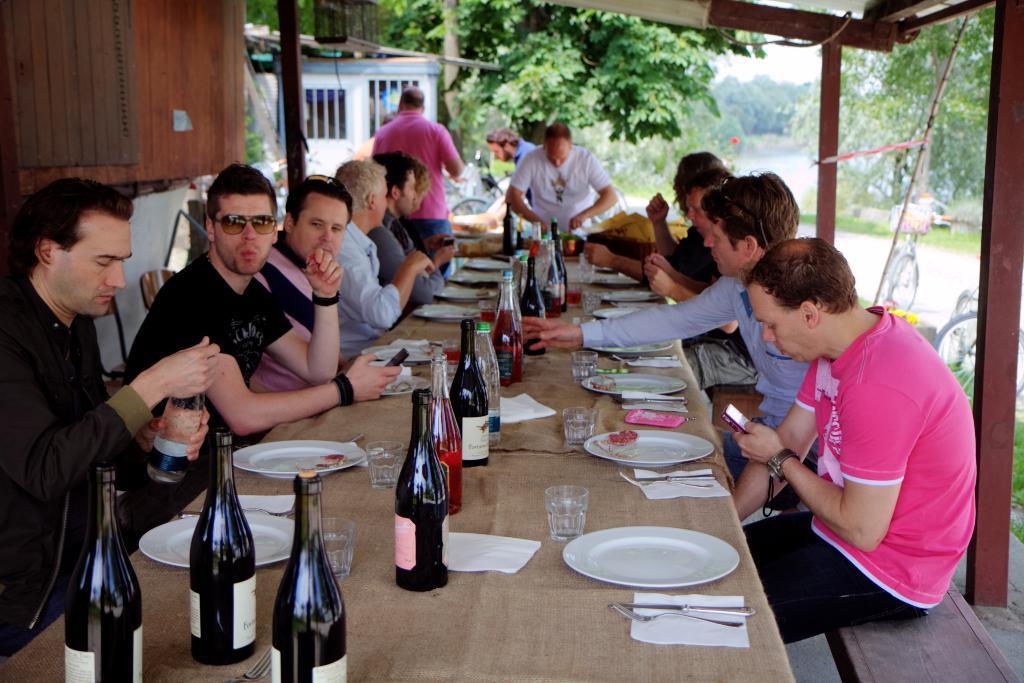In one or two sentences, can you explain what this image depicts? There is a group of people who are sitting on a chair. They are having a food and a wine. In the background there is a tree, a bicycle and a hut. 